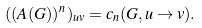<formula> <loc_0><loc_0><loc_500><loc_500>( ( A ( G ) ) ^ { n } ) _ { u v } = c _ { n } ( G , u \rightarrow v ) .</formula> 